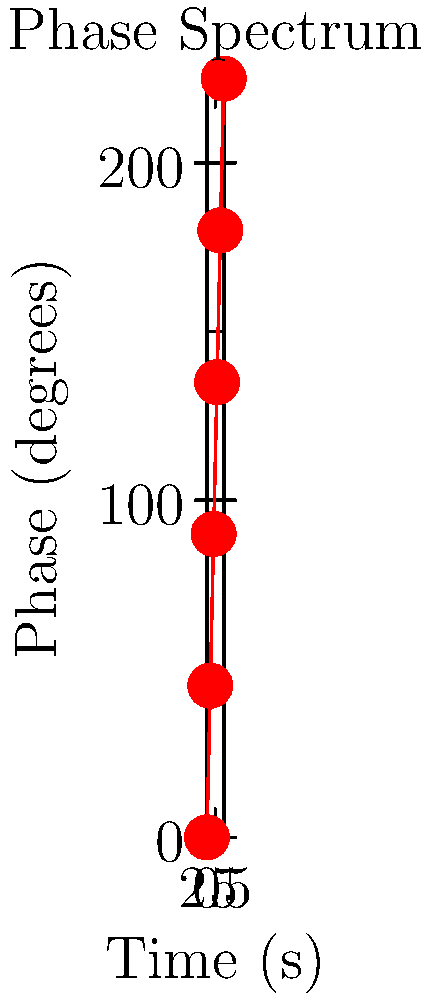Given the phase spectrum of an audio signal shown in the graph, what is the rate of change of phase with respect to time (in degrees per second) between 2 and 4 seconds? To find the rate of change of phase with respect to time between 2 and 4 seconds, we need to follow these steps:

1. Identify the phase values at t = 2s and t = 4s:
   At t = 2s, phase = 90°
   At t = 4s, phase = 180°

2. Calculate the change in phase (Δphase):
   Δphase = 180° - 90° = 90°

3. Calculate the change in time (Δt):
   Δt = 4s - 2s = 2s

4. Calculate the rate of change using the formula:
   Rate of change = Δphase / Δt
   
5. Substitute the values:
   Rate of change = 90° / 2s = 45°/s

Therefore, the rate of change of phase with respect to time between 2 and 4 seconds is 45 degrees per second.
Answer: 45°/s 